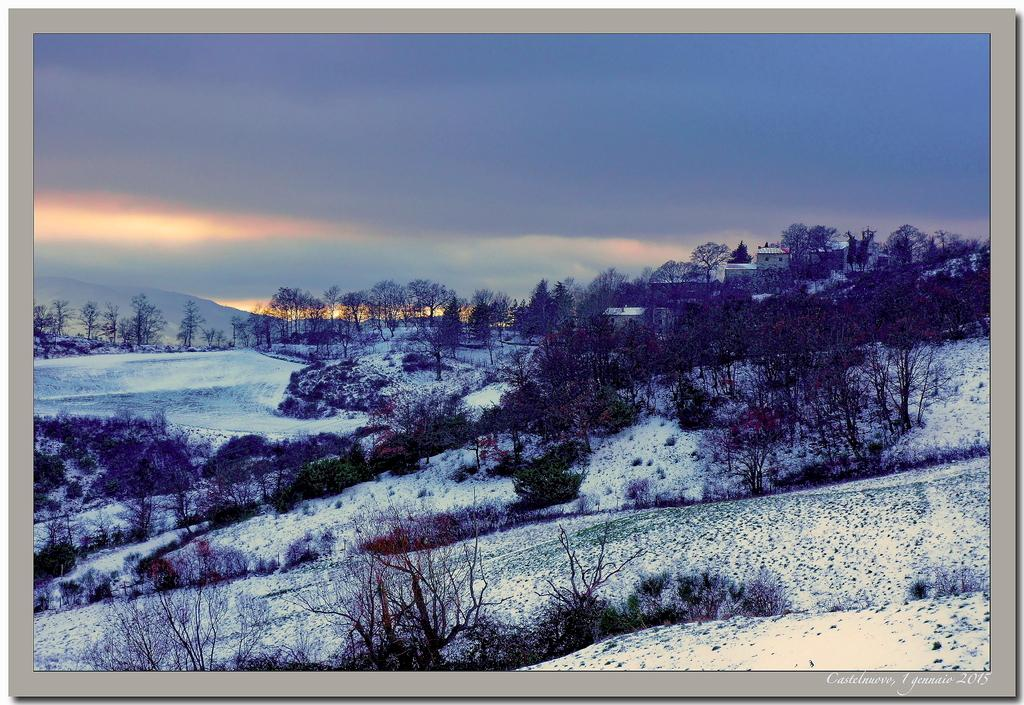What type of natural elements can be seen in the image? There are trees and mountains in the image. What type of man-made structures are present in the image? There are buildings in the image. What is the weather like in the image? There is snow in the image, indicating a cold or wintery environment. What is visible in the background of the image? The sky is visible in the background of the image. Is there any text present in the image? Yes, there is some text in the bottom right corner of the image. Can you tell me what type of pencil is being used to draw the mountains in the image? There is no pencil or drawing activity present in the image; it is a photograph of real trees, buildings, snow, mountains, and sky. What time is displayed on the watch in the image? There is no watch present in the image. 